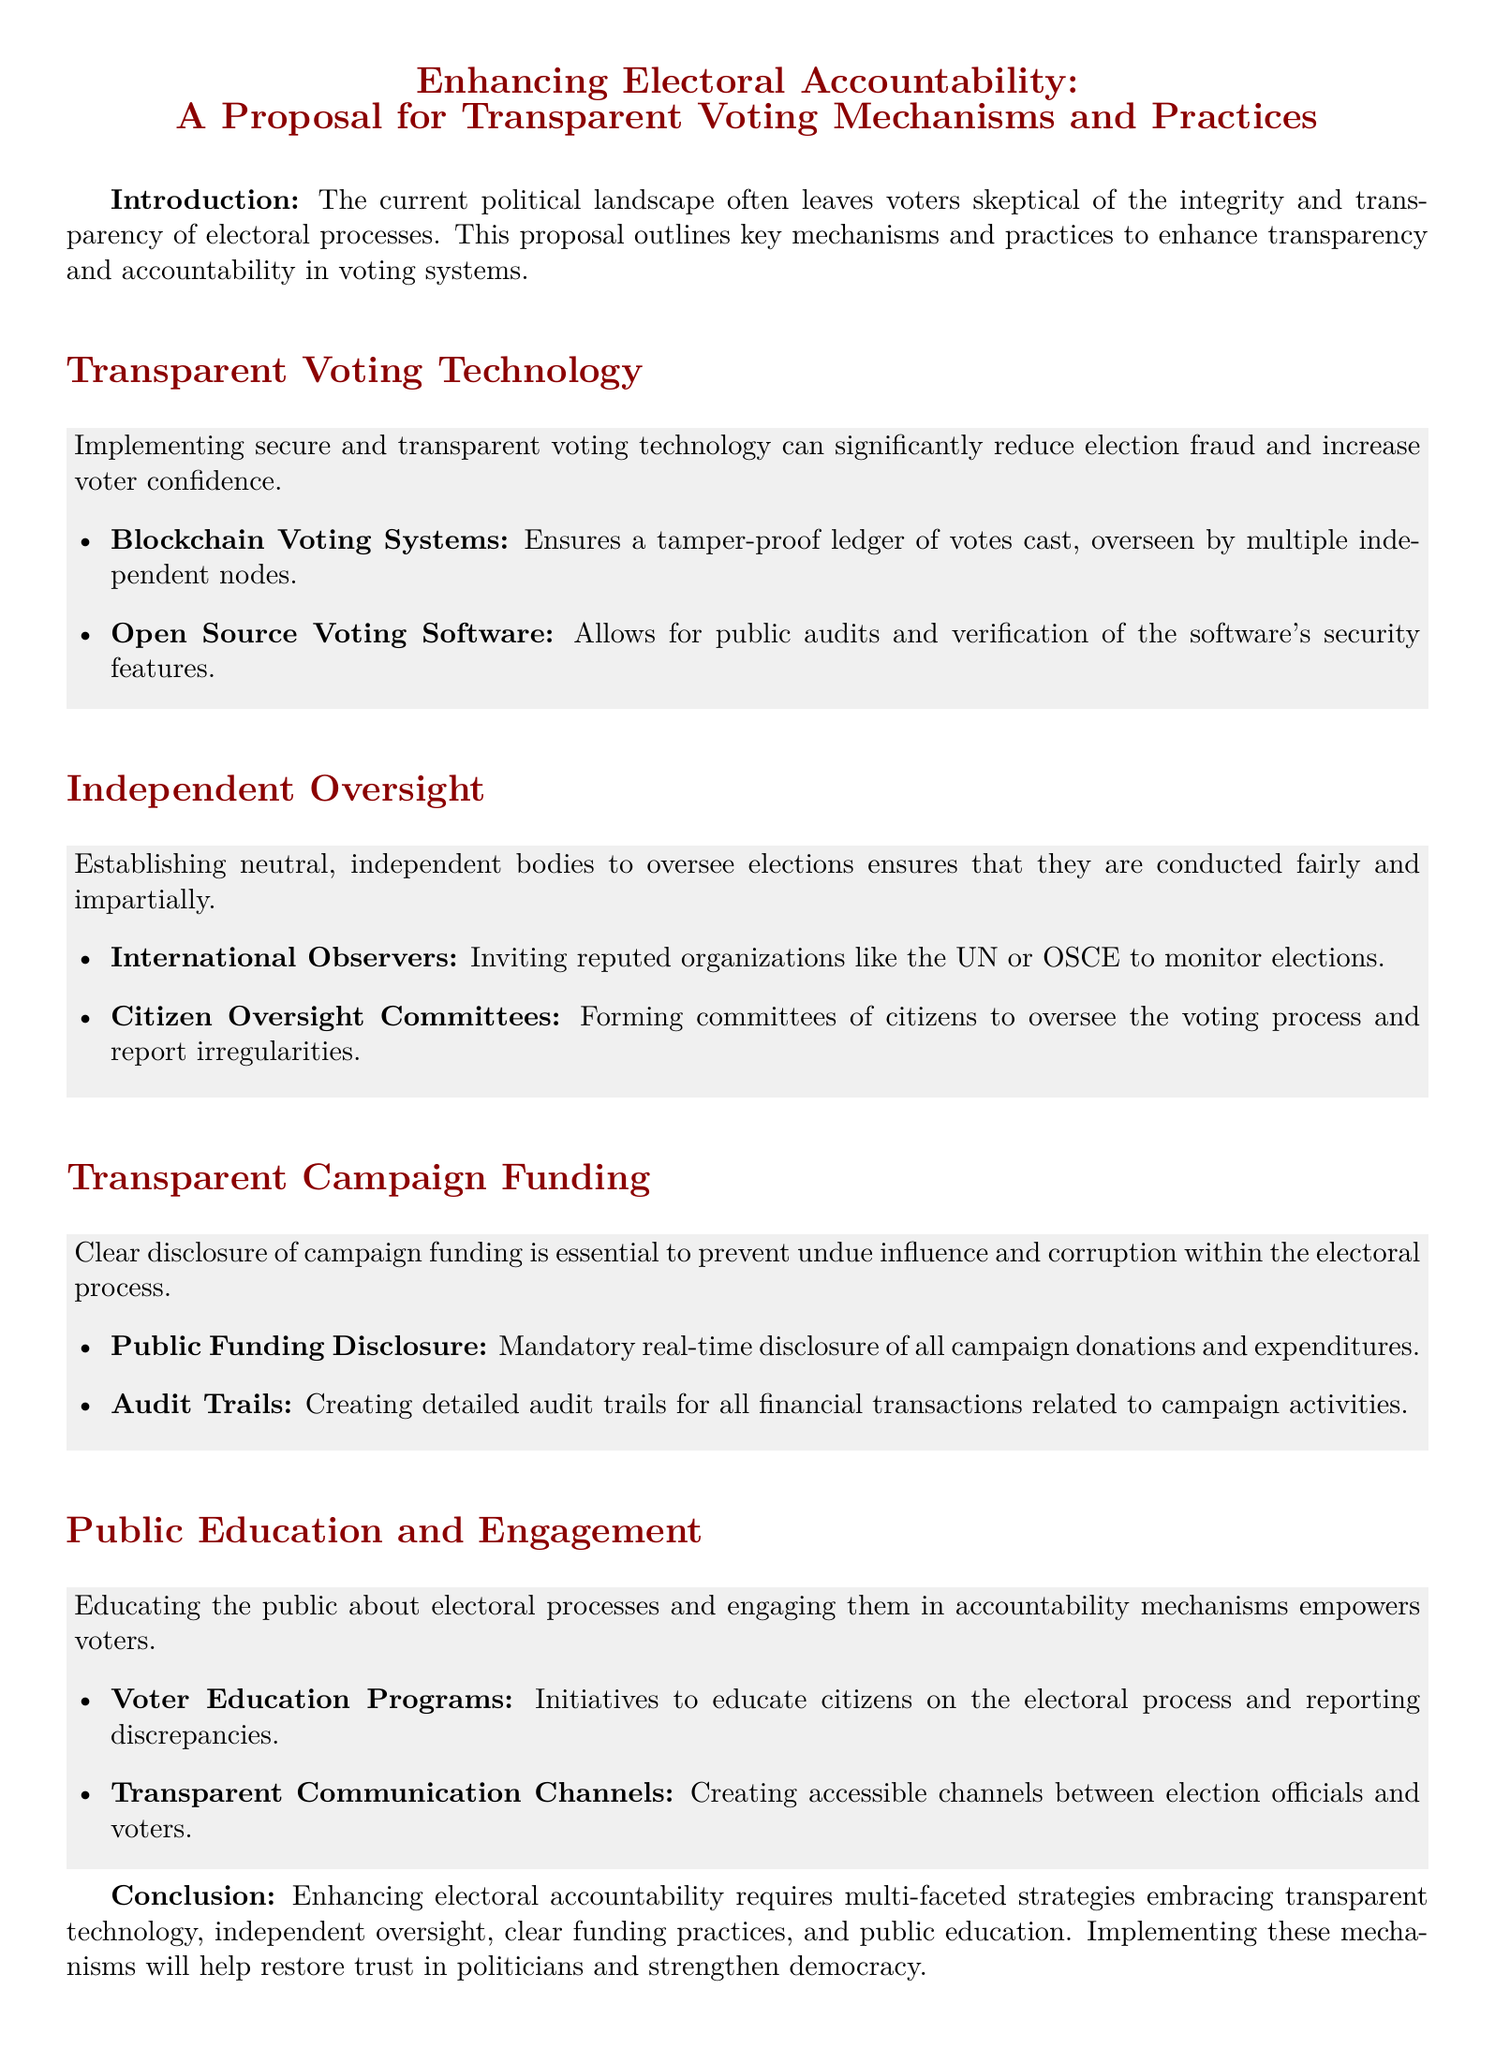What is the title of the proposal? The title of the proposal is presented prominently at the beginning of the document.
Answer: Enhancing Electoral Accountability: A Proposal for Transparent Voting Mechanisms and Practices What technology is suggested for secure voting? The document lists specific technologies in the section about transparent voting technology.
Answer: Blockchain Voting Systems Who are invited as independent observers? The document mentions who can monitor elections in the section on independent oversight.
Answer: International Observers What is required for campaign funding according to the proposal? The document addresses the need for transparency in campaign funding in a specific section.
Answer: Public Funding Disclosure What type of committees are proposed for citizen oversight? The section on independent oversight describes a specific type of citizen-led group.
Answer: Citizen Oversight Committees Which organization is recommended for monitoring elections? The reasoning behind inviting international observers is linked to known organizations in the proposal.
Answer: UN What is a key component of public engagement in elections? The document outlines various initiatives aimed at informing the public about elections.
Answer: Voter Education Programs What is outlined as crucial for transparency in campaiging? The proposal indicates a specific need to prevent corruption during elections.
Answer: Clear disclosure of campaign funding What is emphasized in the conclusion for enhancing trust? The conclusion ties together the proposal's themes and goals.
Answer: Transparent technology 